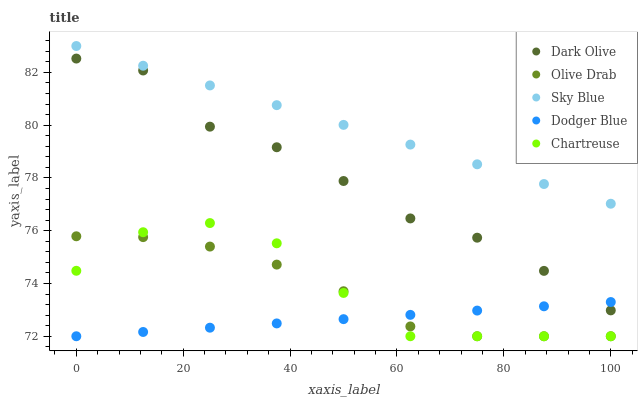Does Dodger Blue have the minimum area under the curve?
Answer yes or no. Yes. Does Sky Blue have the maximum area under the curve?
Answer yes or no. Yes. Does Chartreuse have the minimum area under the curve?
Answer yes or no. No. Does Chartreuse have the maximum area under the curve?
Answer yes or no. No. Is Dodger Blue the smoothest?
Answer yes or no. Yes. Is Chartreuse the roughest?
Answer yes or no. Yes. Is Dark Olive the smoothest?
Answer yes or no. No. Is Dark Olive the roughest?
Answer yes or no. No. Does Chartreuse have the lowest value?
Answer yes or no. Yes. Does Dark Olive have the lowest value?
Answer yes or no. No. Does Sky Blue have the highest value?
Answer yes or no. Yes. Does Chartreuse have the highest value?
Answer yes or no. No. Is Dark Olive less than Sky Blue?
Answer yes or no. Yes. Is Sky Blue greater than Dodger Blue?
Answer yes or no. Yes. Does Dark Olive intersect Dodger Blue?
Answer yes or no. Yes. Is Dark Olive less than Dodger Blue?
Answer yes or no. No. Is Dark Olive greater than Dodger Blue?
Answer yes or no. No. Does Dark Olive intersect Sky Blue?
Answer yes or no. No. 